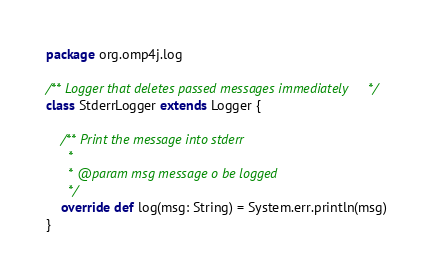<code> <loc_0><loc_0><loc_500><loc_500><_Scala_>package org.omp4j.log

/** Logger that deletes passed messages immediately */
class StderrLogger extends Logger {

	/** Print the message into stderr
	  *
	  * @param msg message o be logged
	  */
	override def log(msg: String) = System.err.println(msg)
}
</code> 